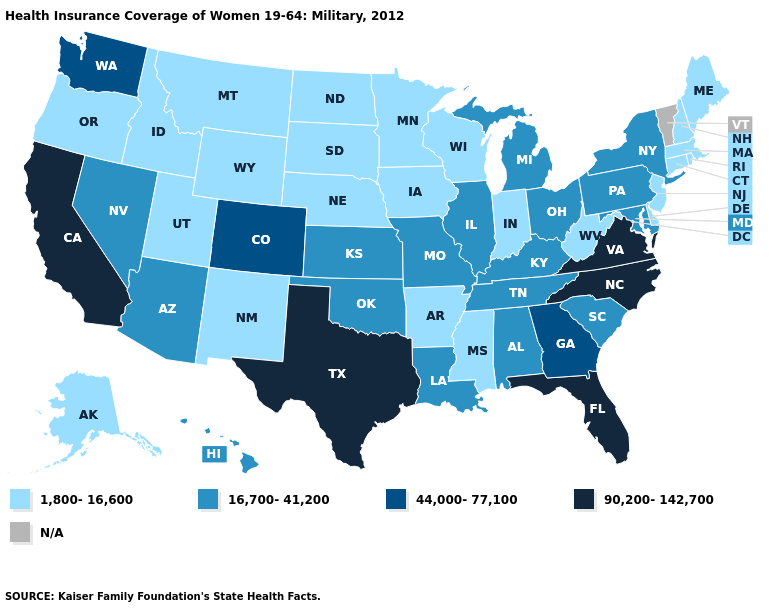What is the value of Arkansas?
Quick response, please. 1,800-16,600. What is the value of Ohio?
Answer briefly. 16,700-41,200. Name the states that have a value in the range 1,800-16,600?
Answer briefly. Alaska, Arkansas, Connecticut, Delaware, Idaho, Indiana, Iowa, Maine, Massachusetts, Minnesota, Mississippi, Montana, Nebraska, New Hampshire, New Jersey, New Mexico, North Dakota, Oregon, Rhode Island, South Dakota, Utah, West Virginia, Wisconsin, Wyoming. What is the highest value in states that border Louisiana?
Quick response, please. 90,200-142,700. Does Georgia have the lowest value in the USA?
Be succinct. No. Does South Dakota have the highest value in the MidWest?
Short answer required. No. Does Florida have the highest value in the USA?
Short answer required. Yes. Name the states that have a value in the range N/A?
Give a very brief answer. Vermont. What is the highest value in the West ?
Give a very brief answer. 90,200-142,700. What is the value of Oregon?
Write a very short answer. 1,800-16,600. Does Rhode Island have the lowest value in the Northeast?
Quick response, please. Yes. Is the legend a continuous bar?
Short answer required. No. Name the states that have a value in the range 44,000-77,100?
Concise answer only. Colorado, Georgia, Washington. Which states have the highest value in the USA?
Concise answer only. California, Florida, North Carolina, Texas, Virginia. Among the states that border New York , does New Jersey have the lowest value?
Answer briefly. Yes. 